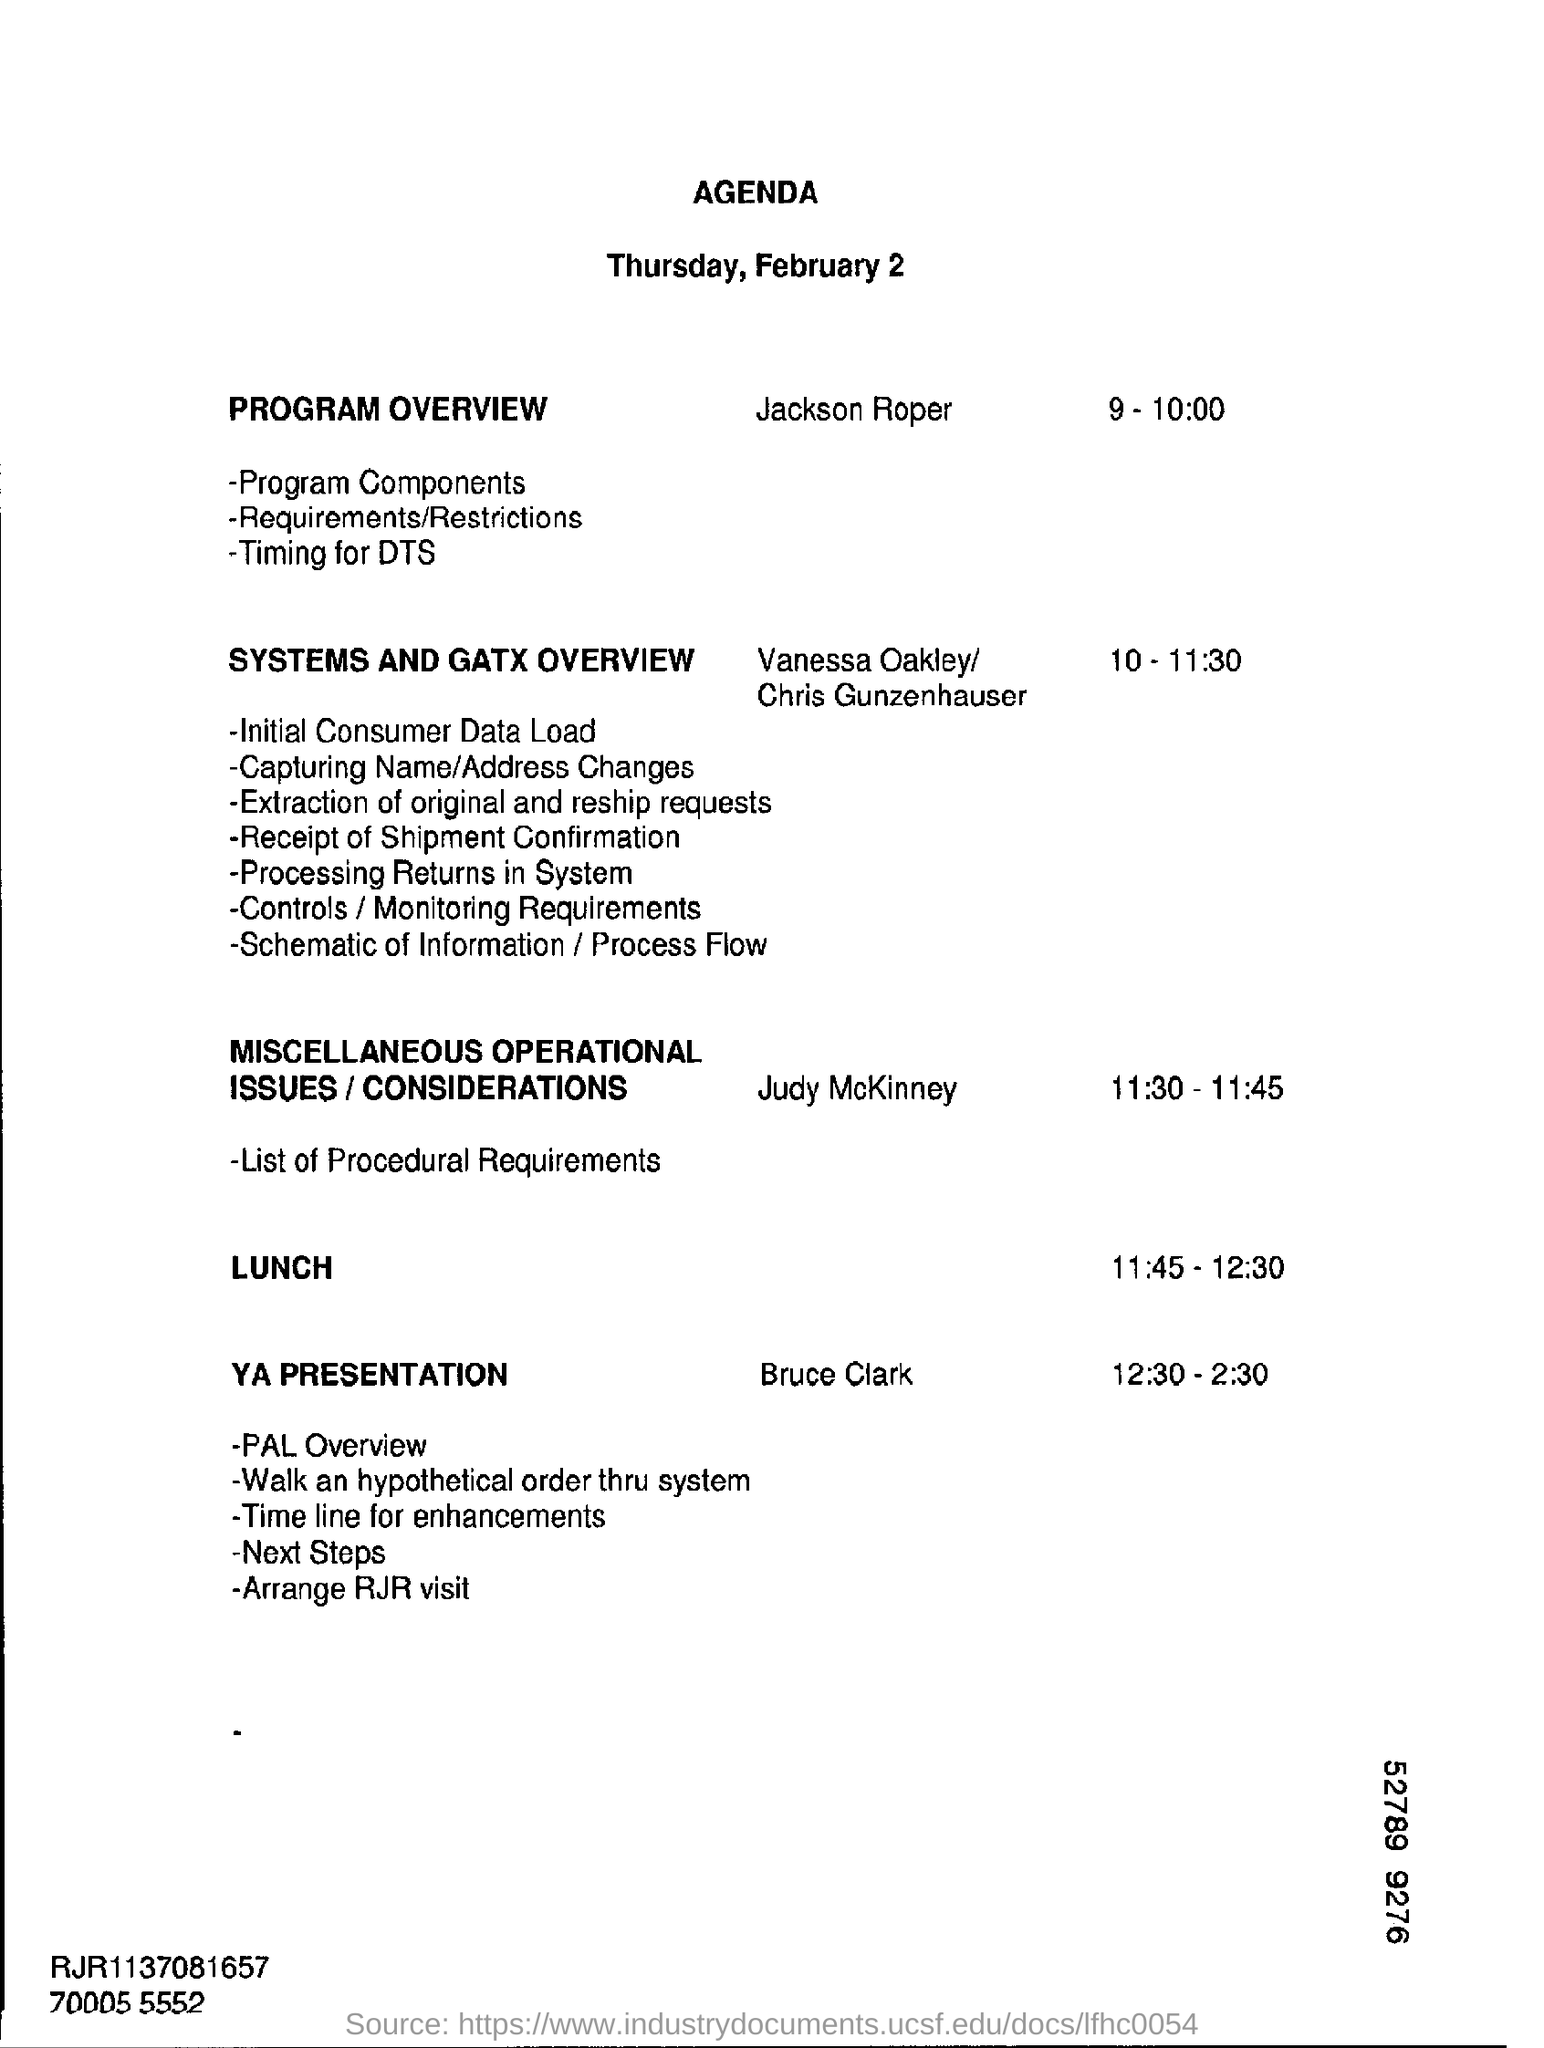Mention a couple of crucial points in this snapshot. The YA presentation is scheduled to take place from 12:30 to 2:30. The Systems and Gatx Overview is scheduled to take place from 10:00 to 11:30. As per the agenda, lunch time is scheduled from 11:45 to 12:30. The speaker introducing the program overview is named Jackson Roper. 